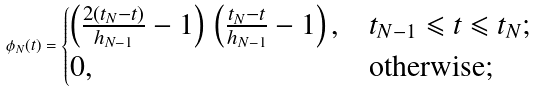<formula> <loc_0><loc_0><loc_500><loc_500>\phi _ { N } ( t ) = \begin{cases} \left ( \frac { 2 ( t _ { N } - t ) } { h _ { N - 1 } } - 1 \right ) \, \left ( \frac { t _ { N } - t } { h _ { N - 1 } } - 1 \right ) , & t _ { N - 1 } \leqslant t \leqslant t _ { N } ; \\ 0 , & \text {otherwise} ; \end{cases}</formula> 